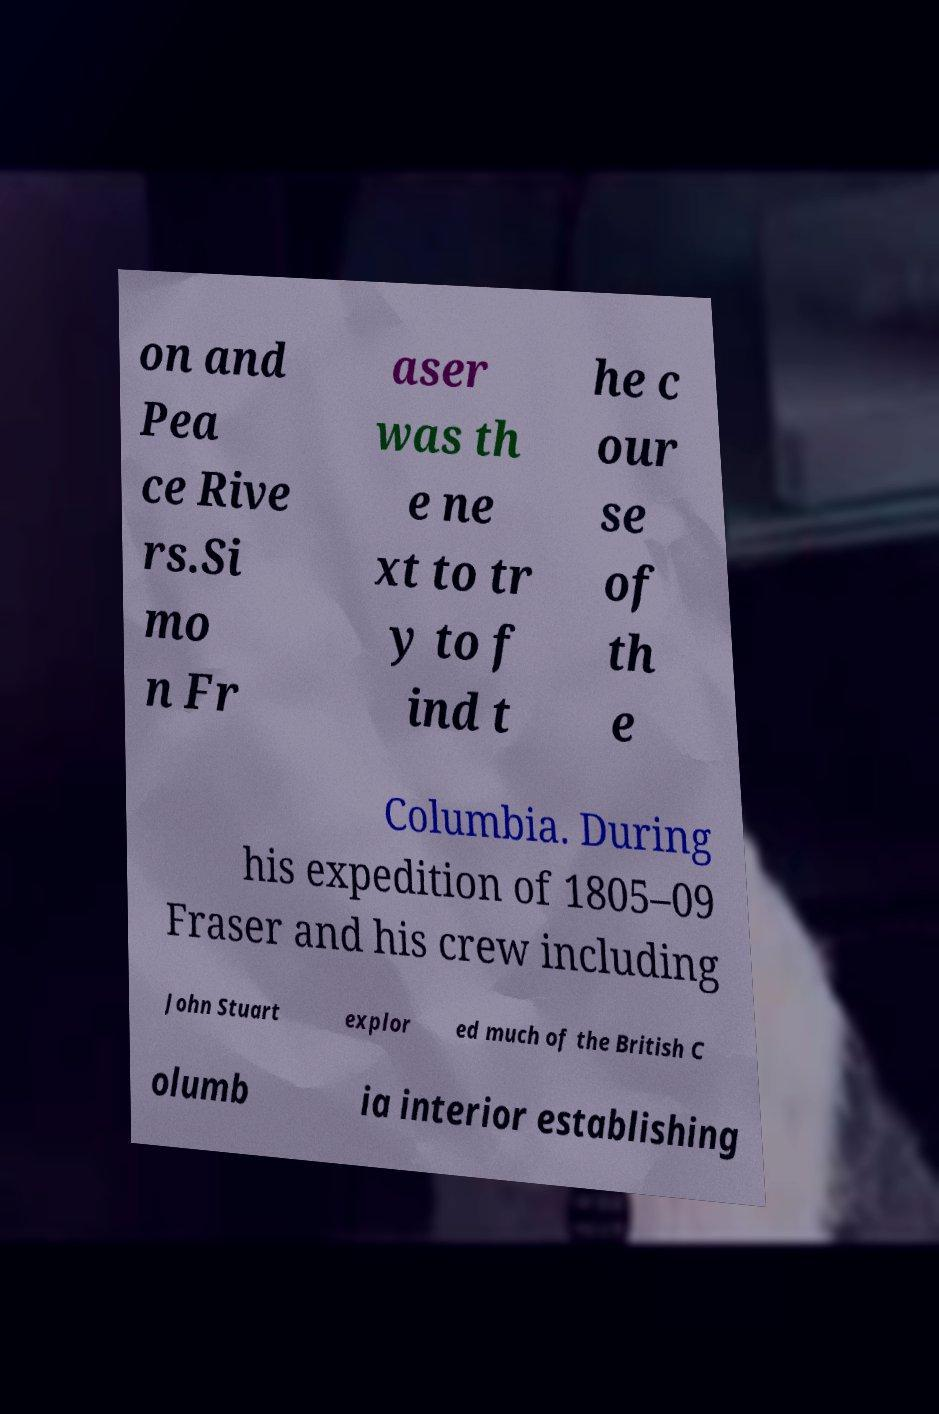Can you accurately transcribe the text from the provided image for me? on and Pea ce Rive rs.Si mo n Fr aser was th e ne xt to tr y to f ind t he c our se of th e Columbia. During his expedition of 1805–09 Fraser and his crew including John Stuart explor ed much of the British C olumb ia interior establishing 